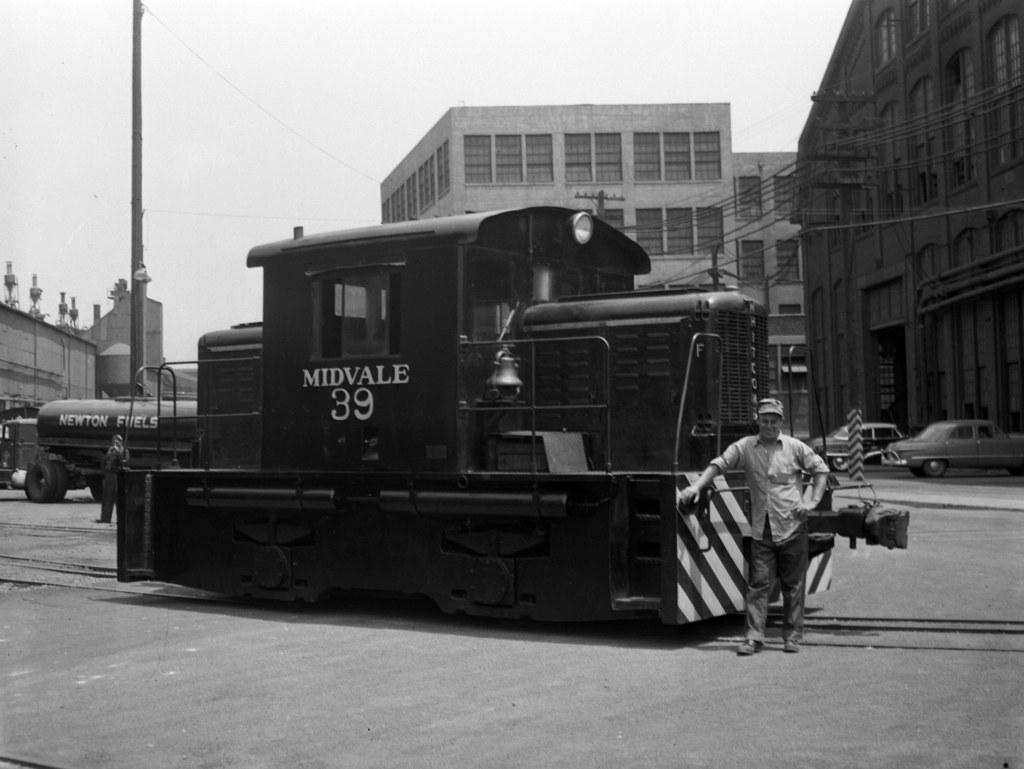Describe this image in one or two sentences. In this image at the center person is standing beside the train. At the background there are buildings, cars. 